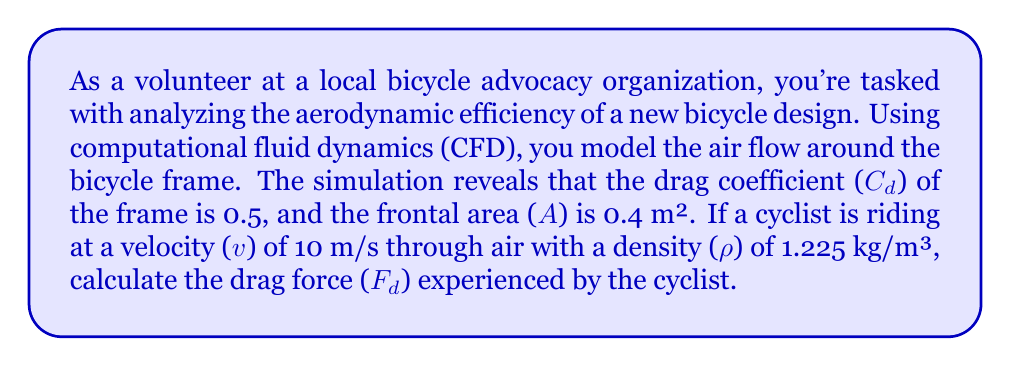What is the answer to this math problem? To solve this problem, we'll use the drag force equation from fluid dynamics:

$$F_d = \frac{1}{2} \rho v^2 C_d A$$

Where:
$F_d$ = drag force (N)
$\rho$ = air density (kg/m³)
$v$ = velocity (m/s)
$C_d$ = drag coefficient (dimensionless)
$A$ = frontal area (m²)

Let's substitute the given values:

$\rho = 1.225$ kg/m³
$v = 10$ m/s
$C_d = 0.5$
$A = 0.4$ m²

Now, let's calculate step by step:

1) $F_d = \frac{1}{2} \times 1.225 \times 10^2 \times 0.5 \times 0.4$

2) $F_d = \frac{1}{2} \times 1.225 \times 100 \times 0.5 \times 0.4$

3) $F_d = 0.5 \times 1.225 \times 50 \times 0.4$

4) $F_d = 12.25$ N

Thus, the drag force experienced by the cyclist is 12.25 N.
Answer: 12.25 N 